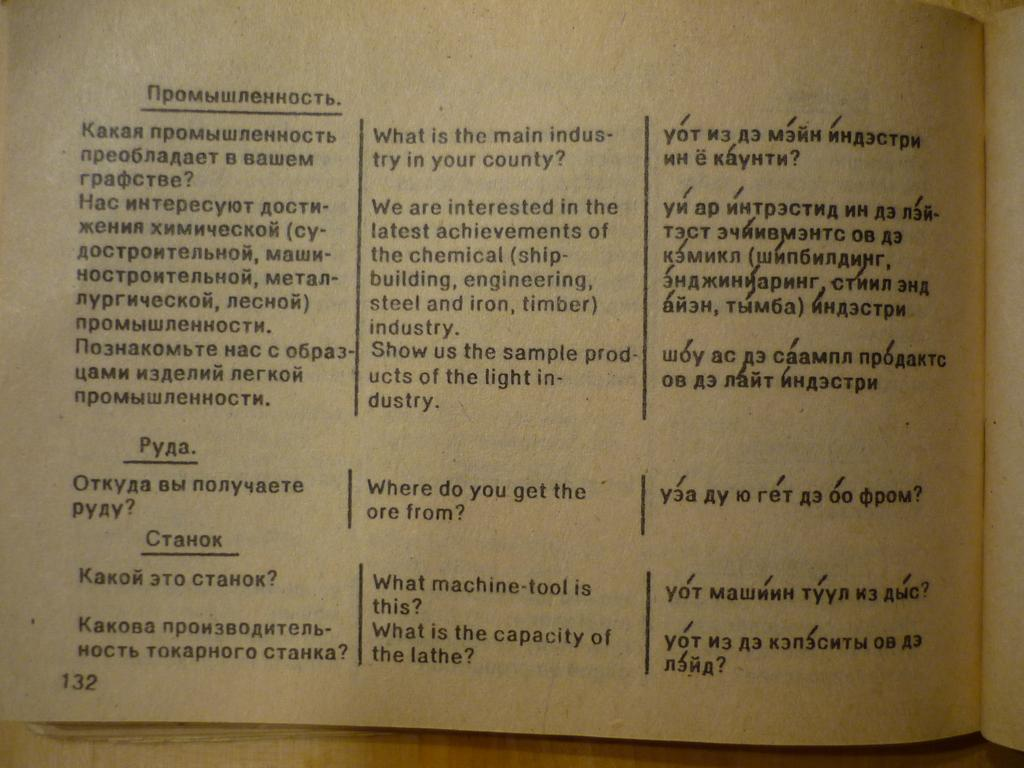<image>
Share a concise interpretation of the image provided. On epage of an Russian to English dictionary looks quite old and worn. 